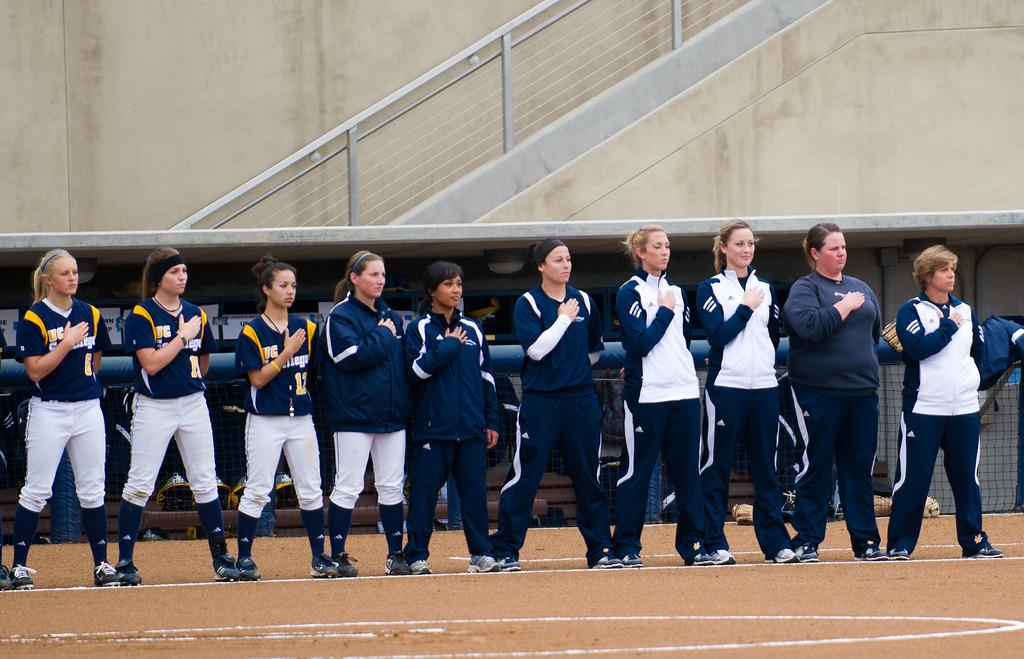How many people are in the image? There is a group of people in the image. What are the people doing in the image? The people are standing on the ground. What are the people wearing in the image? The people are wearing uniforms. What can be seen in the background of the image? There is a fence and a staircase in the background of the image. What is placed on the fence in the image? A coat is placed on the fence. What type of design can be seen on the people's lips in the image? There is no mention of any design on the people's lips in the image; they are wearing uniforms. What kind of pets are visible in the image? There are no pets present in the image. 